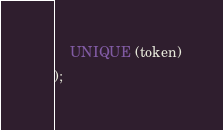<code> <loc_0><loc_0><loc_500><loc_500><_SQL_>    UNIQUE (token)
);</code> 